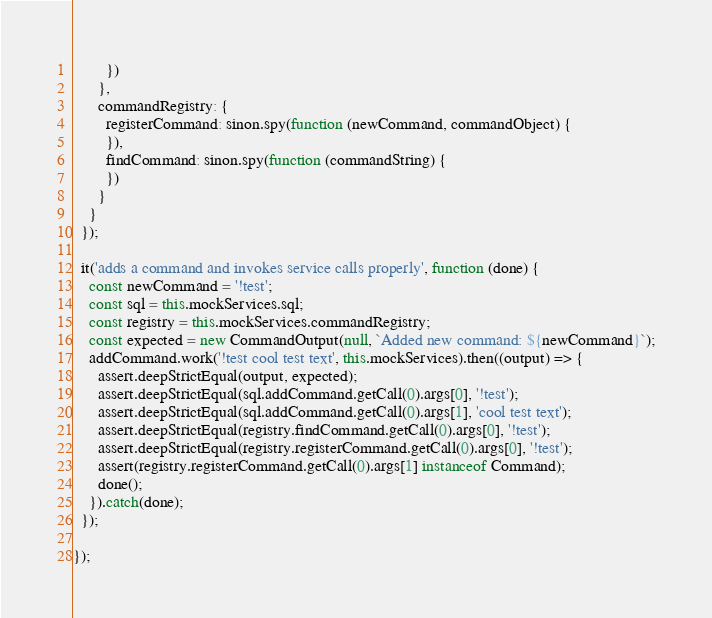Convert code to text. <code><loc_0><loc_0><loc_500><loc_500><_JavaScript_>        })
      },
      commandRegistry: {
        registerCommand: sinon.spy(function (newCommand, commandObject) {
        }),
        findCommand: sinon.spy(function (commandString) {
        })
      }
    }
  });

  it('adds a command and invokes service calls properly', function (done) {
    const newCommand = '!test';
    const sql = this.mockServices.sql;
    const registry = this.mockServices.commandRegistry;
    const expected = new CommandOutput(null, `Added new command: ${newCommand}`);
    addCommand.work('!test cool test text', this.mockServices).then((output) => {
      assert.deepStrictEqual(output, expected);
      assert.deepStrictEqual(sql.addCommand.getCall(0).args[0], '!test');
      assert.deepStrictEqual(sql.addCommand.getCall(0).args[1], 'cool test text');
      assert.deepStrictEqual(registry.findCommand.getCall(0).args[0], '!test');
      assert.deepStrictEqual(registry.registerCommand.getCall(0).args[0], '!test');
      assert(registry.registerCommand.getCall(0).args[1] instanceof Command);
      done();
    }).catch(done);
  });

});

</code> 